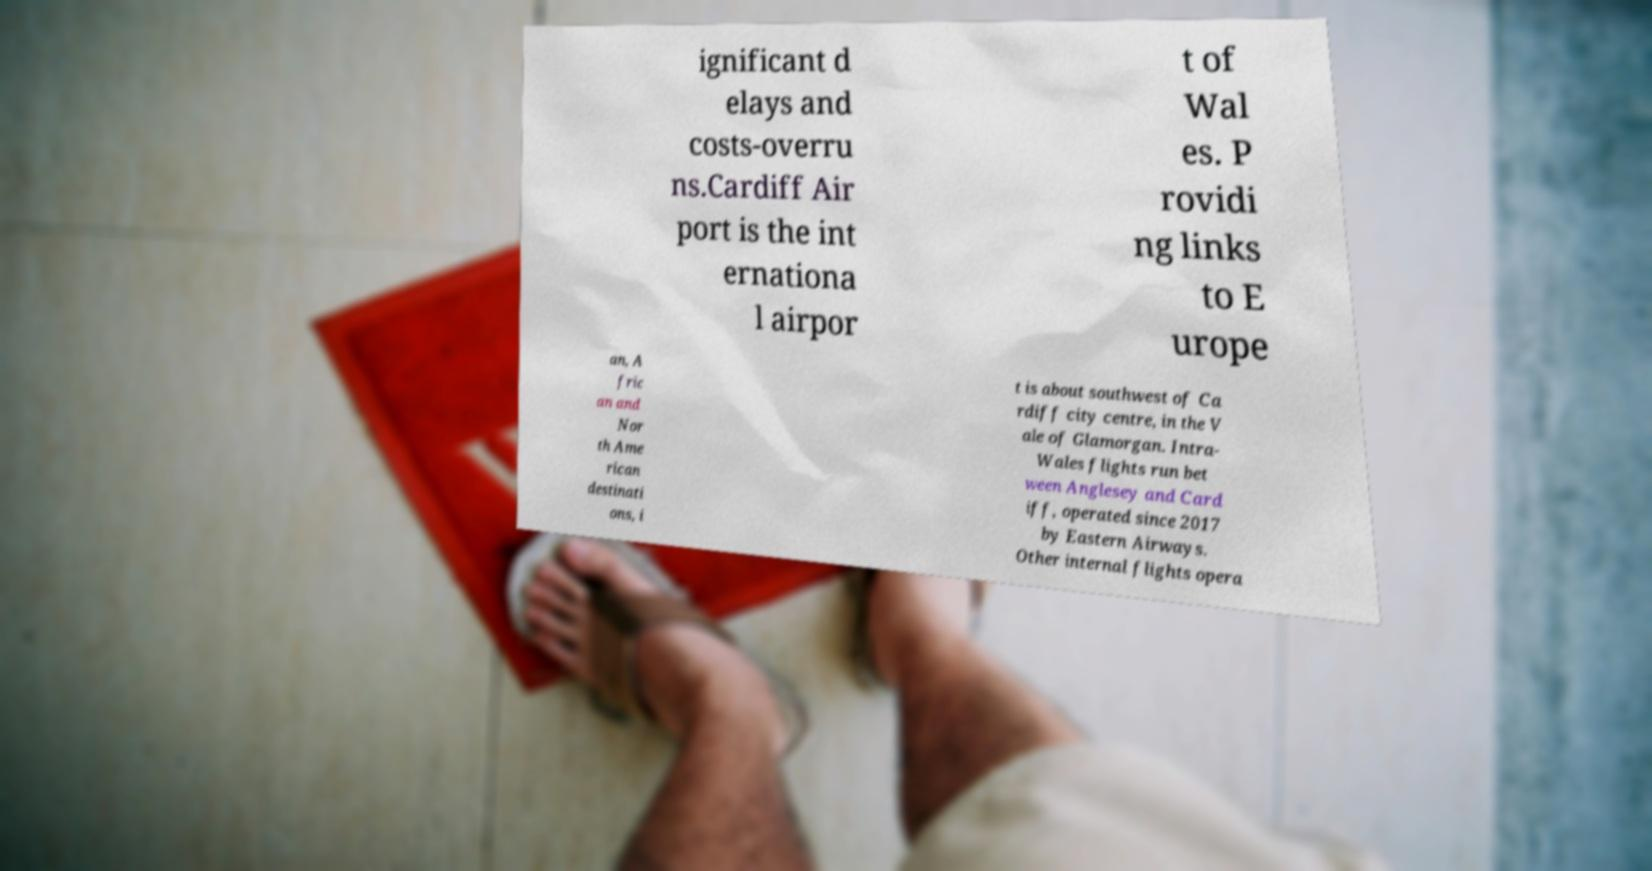Please identify and transcribe the text found in this image. ignificant d elays and costs-overru ns.Cardiff Air port is the int ernationa l airpor t of Wal es. P rovidi ng links to E urope an, A fric an and Nor th Ame rican destinati ons, i t is about southwest of Ca rdiff city centre, in the V ale of Glamorgan. Intra- Wales flights run bet ween Anglesey and Card iff, operated since 2017 by Eastern Airways. Other internal flights opera 